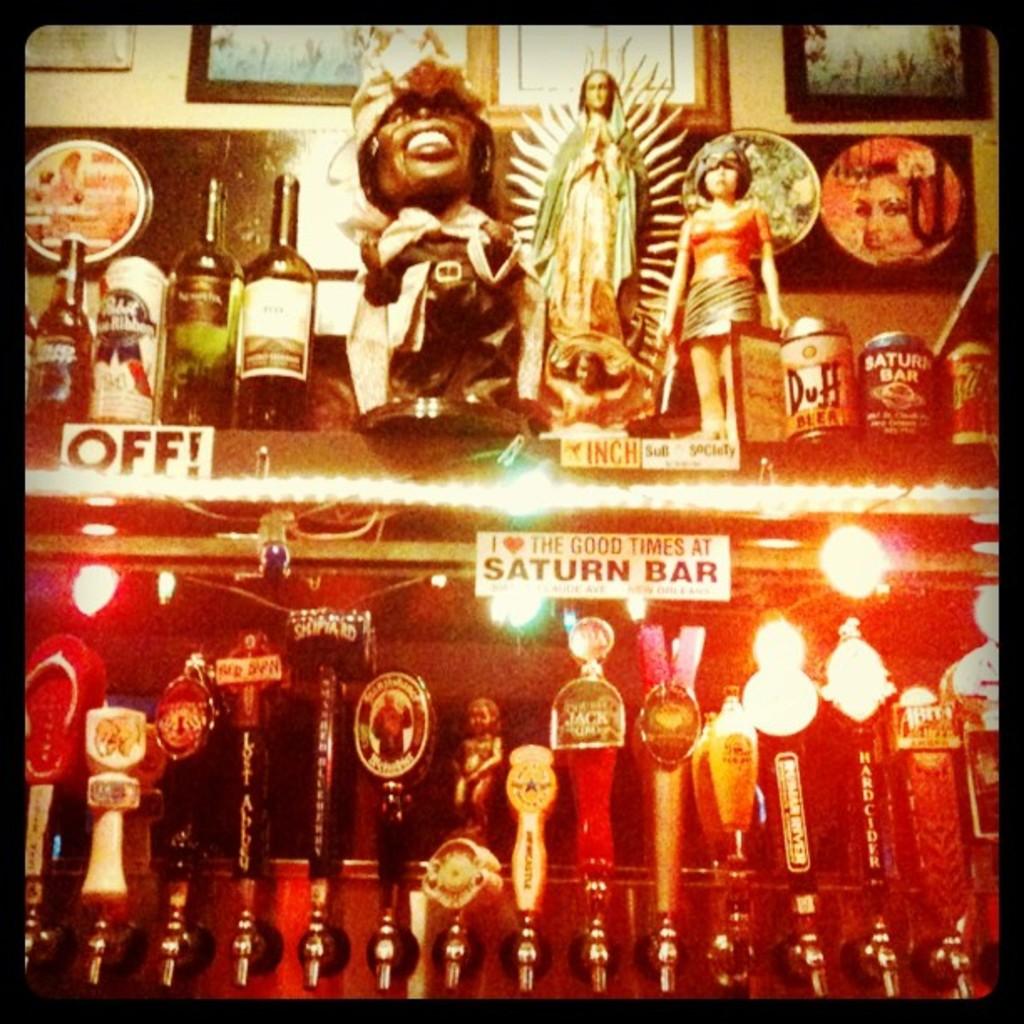What is the name of the bar?
Provide a succinct answer. Saturn bar. What are the three letters on the white rectangle on the middle left?
Provide a succinct answer. Off. 